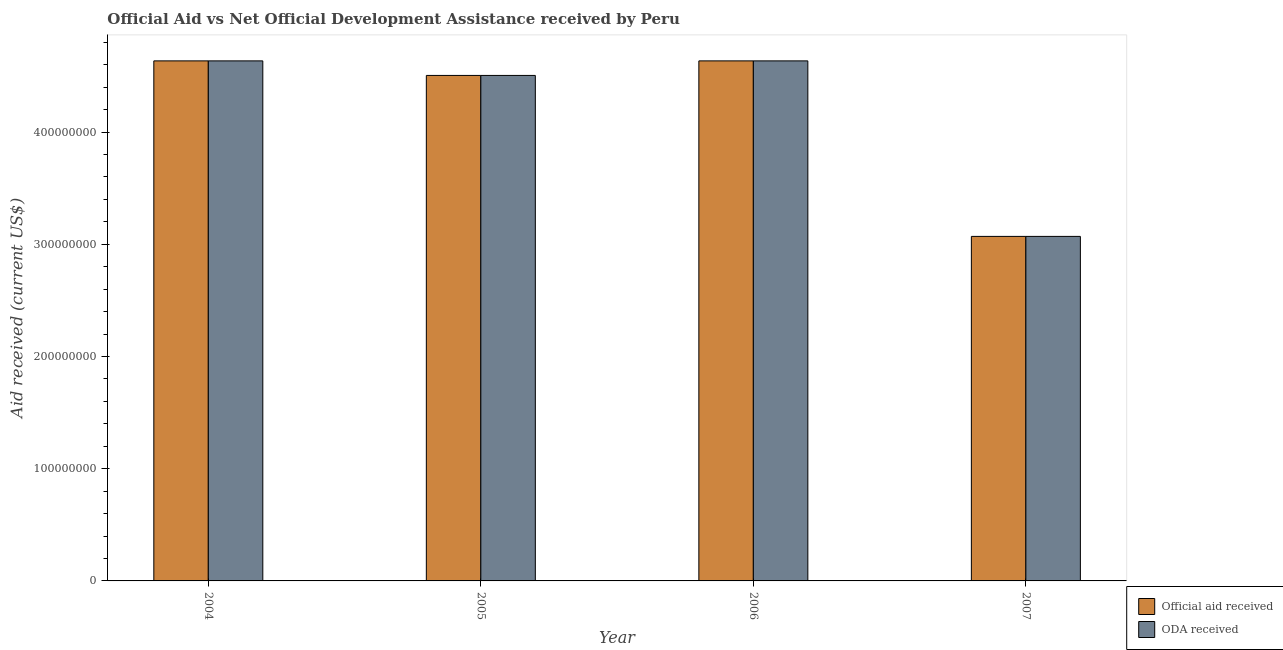How many different coloured bars are there?
Provide a short and direct response. 2. Are the number of bars on each tick of the X-axis equal?
Your answer should be very brief. Yes. How many bars are there on the 3rd tick from the left?
Offer a very short reply. 2. How many bars are there on the 2nd tick from the right?
Keep it short and to the point. 2. In how many cases, is the number of bars for a given year not equal to the number of legend labels?
Provide a short and direct response. 0. What is the oda received in 2006?
Offer a terse response. 4.63e+08. Across all years, what is the maximum oda received?
Offer a terse response. 4.63e+08. Across all years, what is the minimum oda received?
Keep it short and to the point. 3.07e+08. What is the total oda received in the graph?
Your response must be concise. 1.68e+09. What is the difference between the oda received in 2004 and that in 2007?
Give a very brief answer. 1.56e+08. What is the difference between the oda received in 2005 and the official aid received in 2006?
Keep it short and to the point. -1.30e+07. What is the average oda received per year?
Ensure brevity in your answer.  4.21e+08. In the year 2007, what is the difference between the oda received and official aid received?
Your response must be concise. 0. What is the ratio of the official aid received in 2006 to that in 2007?
Your response must be concise. 1.51. Is the difference between the oda received in 2005 and 2006 greater than the difference between the official aid received in 2005 and 2006?
Give a very brief answer. No. What is the difference between the highest and the lowest oda received?
Ensure brevity in your answer.  1.56e+08. What does the 1st bar from the left in 2005 represents?
Keep it short and to the point. Official aid received. What does the 2nd bar from the right in 2006 represents?
Make the answer very short. Official aid received. Are all the bars in the graph horizontal?
Provide a succinct answer. No. How many years are there in the graph?
Give a very brief answer. 4. Are the values on the major ticks of Y-axis written in scientific E-notation?
Offer a very short reply. No. Does the graph contain grids?
Give a very brief answer. No. Where does the legend appear in the graph?
Give a very brief answer. Bottom right. How many legend labels are there?
Your response must be concise. 2. What is the title of the graph?
Provide a short and direct response. Official Aid vs Net Official Development Assistance received by Peru . Does "Foreign liabilities" appear as one of the legend labels in the graph?
Provide a short and direct response. No. What is the label or title of the Y-axis?
Ensure brevity in your answer.  Aid received (current US$). What is the Aid received (current US$) in Official aid received in 2004?
Provide a succinct answer. 4.63e+08. What is the Aid received (current US$) of ODA received in 2004?
Keep it short and to the point. 4.63e+08. What is the Aid received (current US$) in Official aid received in 2005?
Offer a very short reply. 4.50e+08. What is the Aid received (current US$) in ODA received in 2005?
Give a very brief answer. 4.50e+08. What is the Aid received (current US$) in Official aid received in 2006?
Offer a very short reply. 4.63e+08. What is the Aid received (current US$) of ODA received in 2006?
Ensure brevity in your answer.  4.63e+08. What is the Aid received (current US$) in Official aid received in 2007?
Give a very brief answer. 3.07e+08. What is the Aid received (current US$) of ODA received in 2007?
Keep it short and to the point. 3.07e+08. Across all years, what is the maximum Aid received (current US$) of Official aid received?
Ensure brevity in your answer.  4.63e+08. Across all years, what is the maximum Aid received (current US$) in ODA received?
Offer a very short reply. 4.63e+08. Across all years, what is the minimum Aid received (current US$) of Official aid received?
Make the answer very short. 3.07e+08. Across all years, what is the minimum Aid received (current US$) of ODA received?
Give a very brief answer. 3.07e+08. What is the total Aid received (current US$) of Official aid received in the graph?
Offer a very short reply. 1.68e+09. What is the total Aid received (current US$) of ODA received in the graph?
Make the answer very short. 1.68e+09. What is the difference between the Aid received (current US$) of Official aid received in 2004 and that in 2005?
Your answer should be very brief. 1.30e+07. What is the difference between the Aid received (current US$) in ODA received in 2004 and that in 2005?
Your answer should be very brief. 1.30e+07. What is the difference between the Aid received (current US$) in ODA received in 2004 and that in 2006?
Ensure brevity in your answer.  10000. What is the difference between the Aid received (current US$) of Official aid received in 2004 and that in 2007?
Your answer should be very brief. 1.56e+08. What is the difference between the Aid received (current US$) in ODA received in 2004 and that in 2007?
Your response must be concise. 1.56e+08. What is the difference between the Aid received (current US$) in Official aid received in 2005 and that in 2006?
Provide a short and direct response. -1.30e+07. What is the difference between the Aid received (current US$) of ODA received in 2005 and that in 2006?
Your answer should be very brief. -1.30e+07. What is the difference between the Aid received (current US$) in Official aid received in 2005 and that in 2007?
Keep it short and to the point. 1.43e+08. What is the difference between the Aid received (current US$) of ODA received in 2005 and that in 2007?
Make the answer very short. 1.43e+08. What is the difference between the Aid received (current US$) of Official aid received in 2006 and that in 2007?
Keep it short and to the point. 1.56e+08. What is the difference between the Aid received (current US$) in ODA received in 2006 and that in 2007?
Your answer should be very brief. 1.56e+08. What is the difference between the Aid received (current US$) in Official aid received in 2004 and the Aid received (current US$) in ODA received in 2005?
Ensure brevity in your answer.  1.30e+07. What is the difference between the Aid received (current US$) of Official aid received in 2004 and the Aid received (current US$) of ODA received in 2007?
Your answer should be very brief. 1.56e+08. What is the difference between the Aid received (current US$) of Official aid received in 2005 and the Aid received (current US$) of ODA received in 2006?
Provide a short and direct response. -1.30e+07. What is the difference between the Aid received (current US$) of Official aid received in 2005 and the Aid received (current US$) of ODA received in 2007?
Your answer should be compact. 1.43e+08. What is the difference between the Aid received (current US$) in Official aid received in 2006 and the Aid received (current US$) in ODA received in 2007?
Give a very brief answer. 1.56e+08. What is the average Aid received (current US$) of Official aid received per year?
Ensure brevity in your answer.  4.21e+08. What is the average Aid received (current US$) in ODA received per year?
Ensure brevity in your answer.  4.21e+08. In the year 2004, what is the difference between the Aid received (current US$) of Official aid received and Aid received (current US$) of ODA received?
Your answer should be very brief. 0. What is the ratio of the Aid received (current US$) of Official aid received in 2004 to that in 2005?
Provide a short and direct response. 1.03. What is the ratio of the Aid received (current US$) of ODA received in 2004 to that in 2005?
Give a very brief answer. 1.03. What is the ratio of the Aid received (current US$) in Official aid received in 2004 to that in 2006?
Your response must be concise. 1. What is the ratio of the Aid received (current US$) of ODA received in 2004 to that in 2006?
Make the answer very short. 1. What is the ratio of the Aid received (current US$) of Official aid received in 2004 to that in 2007?
Your answer should be compact. 1.51. What is the ratio of the Aid received (current US$) of ODA received in 2004 to that in 2007?
Provide a short and direct response. 1.51. What is the ratio of the Aid received (current US$) in Official aid received in 2005 to that in 2006?
Offer a terse response. 0.97. What is the ratio of the Aid received (current US$) in Official aid received in 2005 to that in 2007?
Your answer should be compact. 1.47. What is the ratio of the Aid received (current US$) of ODA received in 2005 to that in 2007?
Give a very brief answer. 1.47. What is the ratio of the Aid received (current US$) in Official aid received in 2006 to that in 2007?
Keep it short and to the point. 1.51. What is the ratio of the Aid received (current US$) of ODA received in 2006 to that in 2007?
Keep it short and to the point. 1.51. What is the difference between the highest and the lowest Aid received (current US$) in Official aid received?
Your answer should be very brief. 1.56e+08. What is the difference between the highest and the lowest Aid received (current US$) in ODA received?
Your response must be concise. 1.56e+08. 